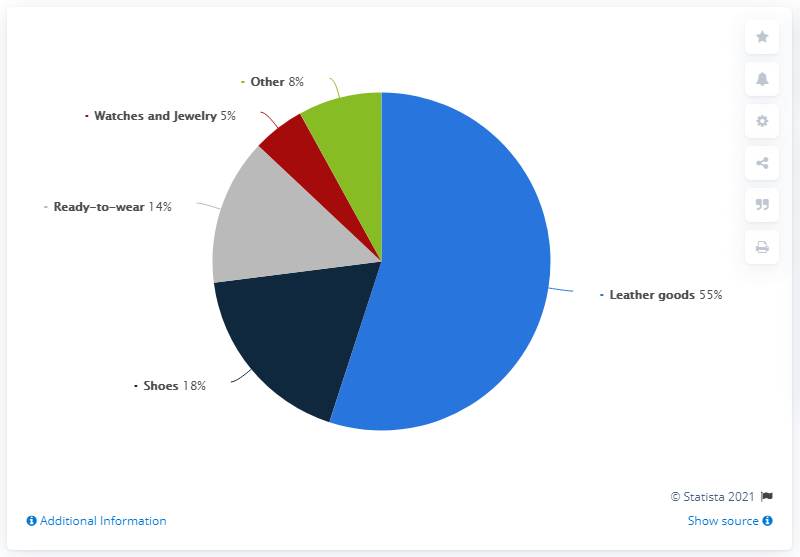Highlight a few significant elements in this photo. Leather goods are the product that contribute the largest share to our sales revenue. The combined share of shoes, ready-to-wear, and watches and jewelry is 37%. 